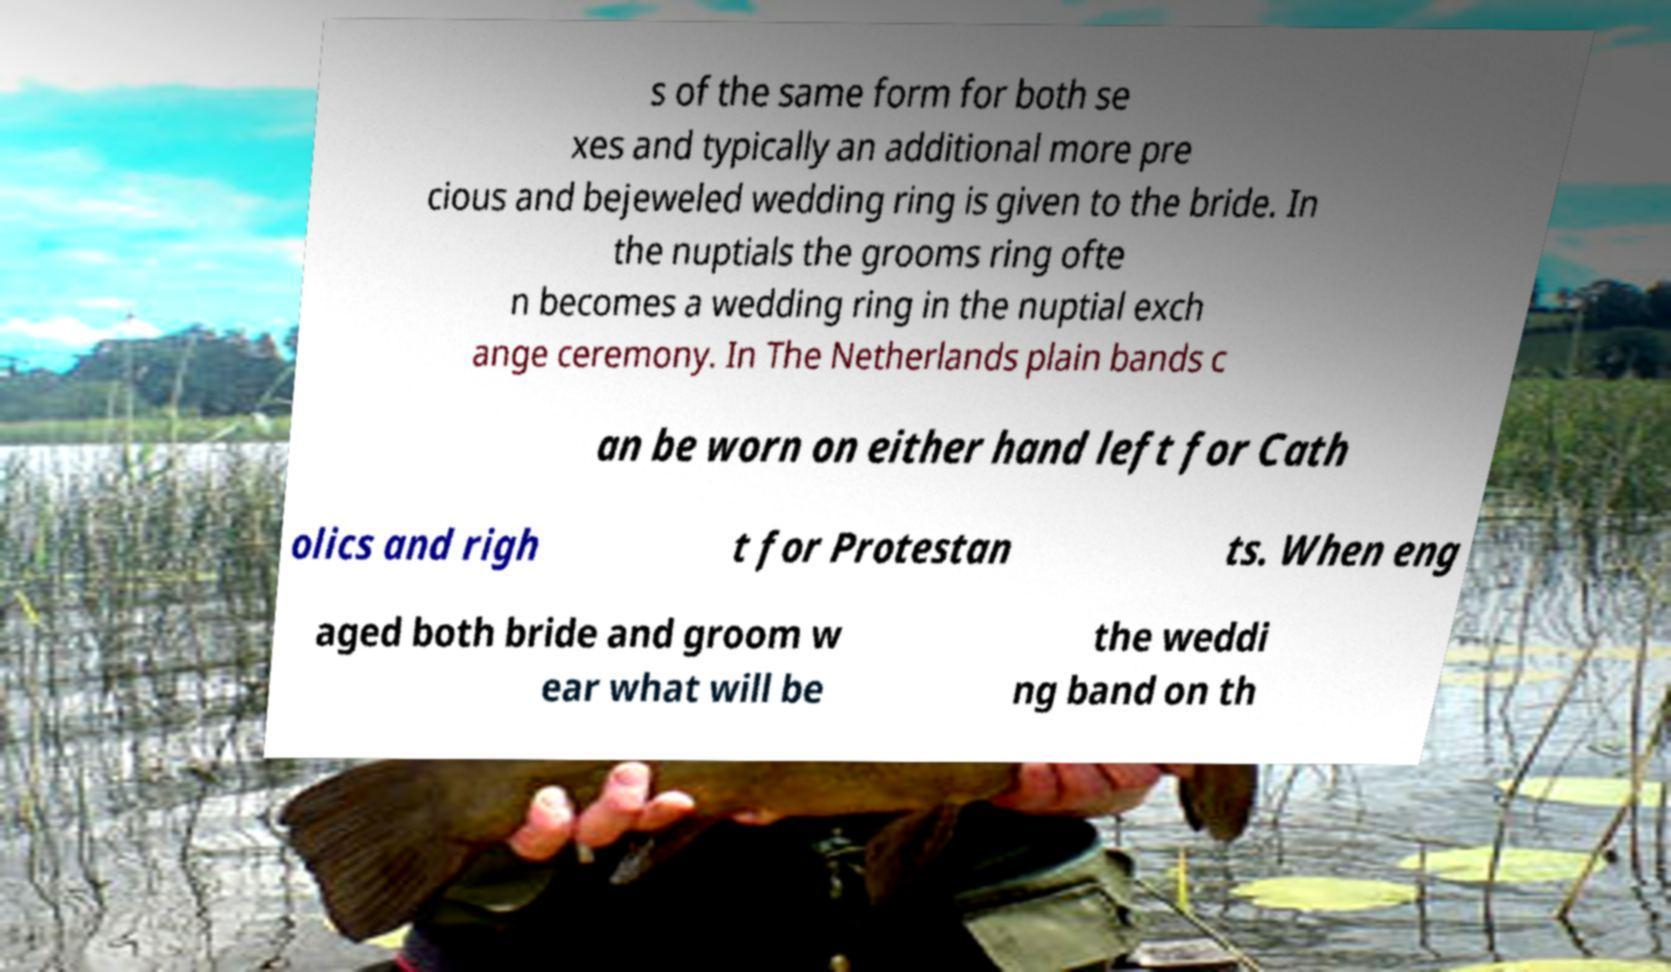Please identify and transcribe the text found in this image. s of the same form for both se xes and typically an additional more pre cious and bejeweled wedding ring is given to the bride. In the nuptials the grooms ring ofte n becomes a wedding ring in the nuptial exch ange ceremony. In The Netherlands plain bands c an be worn on either hand left for Cath olics and righ t for Protestan ts. When eng aged both bride and groom w ear what will be the weddi ng band on th 